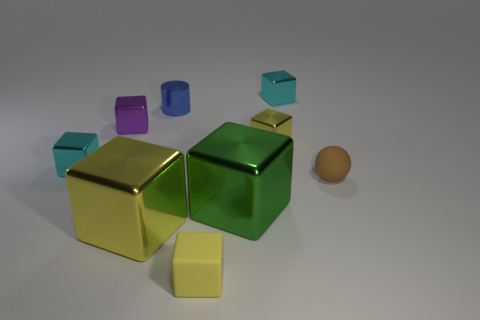Is the shape of the large green thing the same as the yellow object that is on the right side of the yellow matte block?
Provide a succinct answer. Yes. There is a tiny object that is the same color as the small rubber cube; what shape is it?
Your response must be concise. Cube. Is the number of tiny cylinders behind the small blue cylinder less than the number of small cyan objects?
Offer a very short reply. Yes. Is the big yellow object the same shape as the tiny purple object?
Give a very brief answer. Yes. What is the size of the yellow thing that is the same material as the tiny brown sphere?
Your response must be concise. Small. Is the number of large red matte cylinders less than the number of small balls?
Your answer should be compact. Yes. What number of small objects are either purple cubes or brown matte balls?
Keep it short and to the point. 2. How many tiny cubes are to the left of the tiny yellow metallic thing and behind the sphere?
Your answer should be compact. 2. Is the number of small blue metallic things greater than the number of tiny cyan things?
Make the answer very short. No. How many other objects are the same shape as the big green metal object?
Keep it short and to the point. 6. 